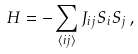<formula> <loc_0><loc_0><loc_500><loc_500>H = - \sum _ { \langle i j \rangle } J _ { i j } { S } _ { i } { S } _ { j } \, ,</formula> 